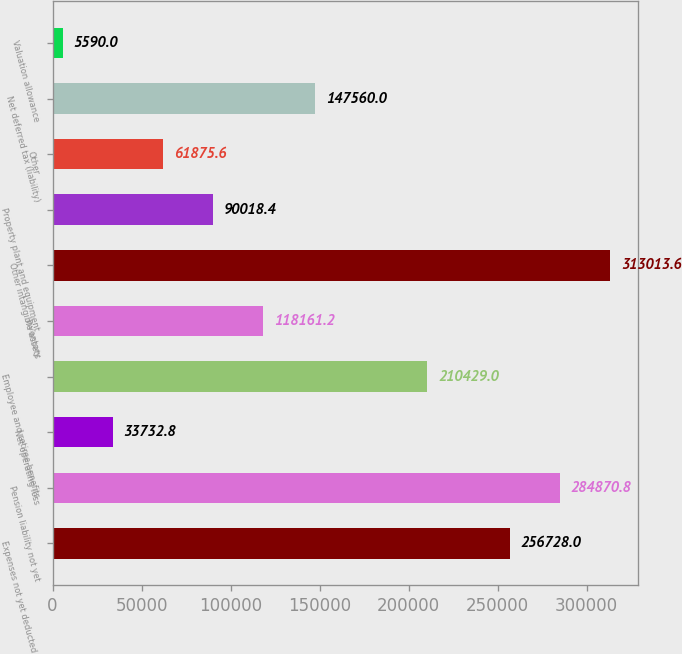Convert chart to OTSL. <chart><loc_0><loc_0><loc_500><loc_500><bar_chart><fcel>Expenses not yet deducted for<fcel>Pension liability not yet<fcel>Net operating loss<fcel>Employee and retiree benefits<fcel>Inventory<fcel>Other intangible assets<fcel>Property plant and equipment<fcel>Other<fcel>Net deferred tax (liability)<fcel>Valuation allowance<nl><fcel>256728<fcel>284871<fcel>33732.8<fcel>210429<fcel>118161<fcel>313014<fcel>90018.4<fcel>61875.6<fcel>147560<fcel>5590<nl></chart> 